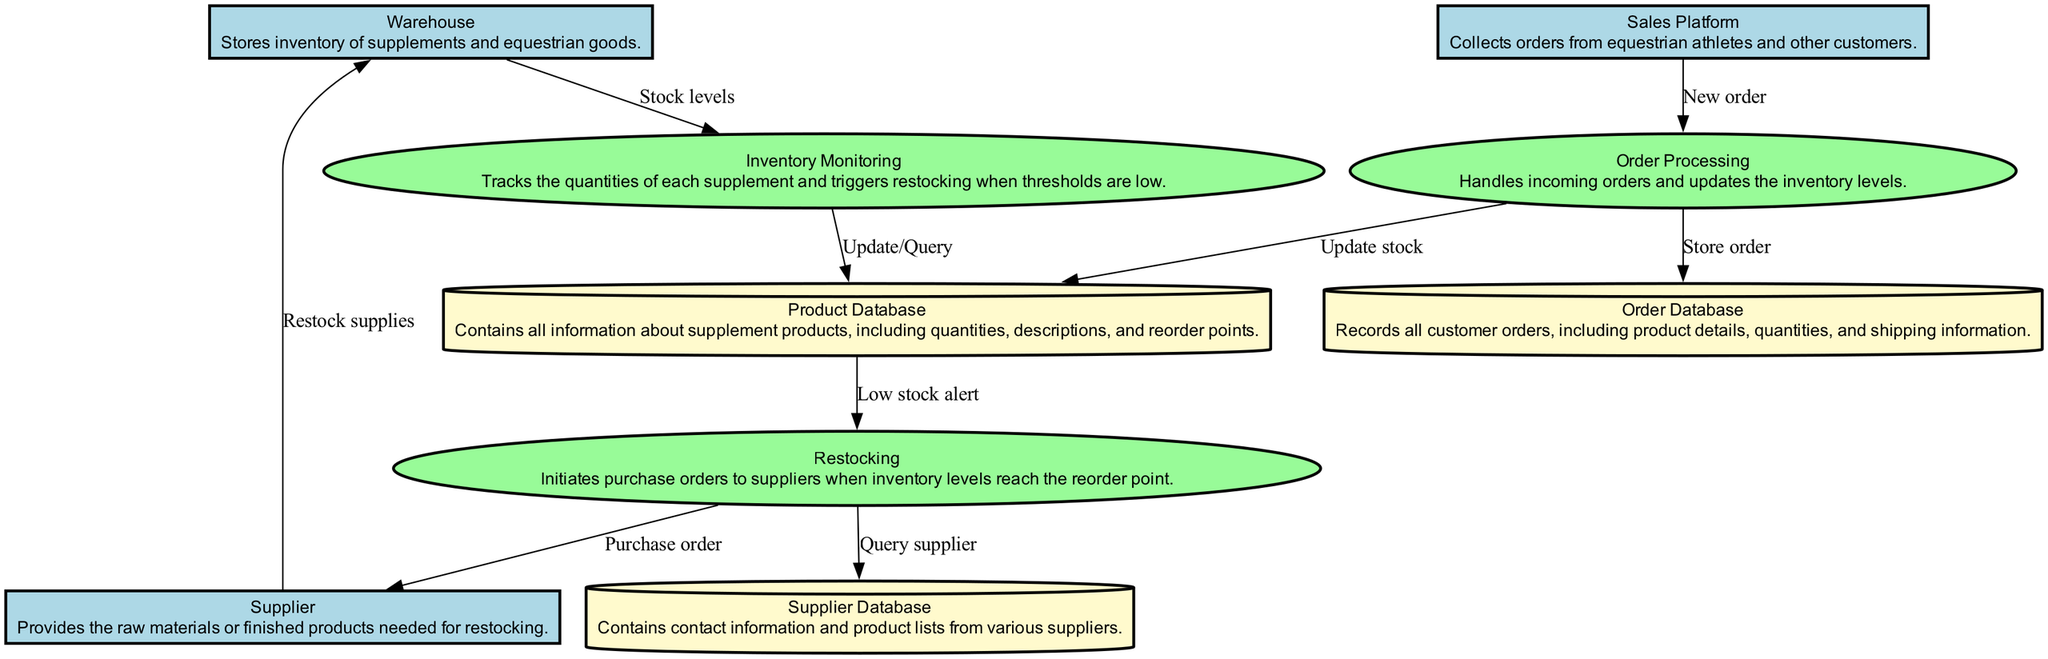What is the role of the Warehouse in the system? The Warehouse is labeled as an "External Entity" that "Stores inventory of supplements and equestrian goods," indicating its primary function within the system.
Answer: Stores inventory of supplements and equestrian goods How many external entities are in the diagram? By examining the diagram, there are three external entities listed: Warehouse, Supplier, and Sales Platform.
Answer: Three Which process is responsible for updating the inventory levels after an order is received? The diagram shows that the "Order Processing" handles incoming orders and updates the inventory levels, highlighting this responsibility.
Answer: Order Processing What does the Restocking process trigger? According to the relationships in the diagram, the Restocking process initiates a "Purchase order" to the Supplier when inventory levels reach the reorder point.
Answer: Purchase order How does Inventory Monitoring interact with Product Database? The Inventory Monitoring process "Updates/Queries" the Product Database, establishing a direct relationship between tracking stock levels and accessing product information.
Answer: Update/Query What database records customer orders? The diagram explicitly indicates that the "Order Database" is responsible for recording all customer orders, which includes details such as product and shipping information.
Answer: Order Database What action does the Supplier take in response to the Restocking process? The diagram illustrates that the Supplier supplies the Warehouse with restocked items as a result of the Purchase order from the Restocking process.
Answer: Restock supplies What type of information does the Supplier Database contain? The Supplier Database is described as containing "contact information and product lists from various suppliers," specifying its role in the system's data management.
Answer: Contact information and product lists What triggers the Restocking process? The Restocking process is triggered by "Low stock alert" messages that come from the Product Database, indicating the need to restock items.
Answer: Low stock alert 